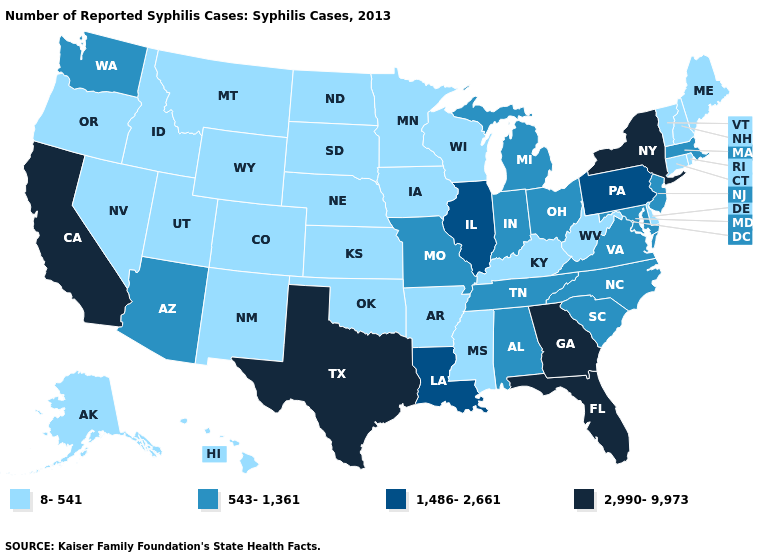What is the value of Alaska?
Keep it brief. 8-541. What is the value of Illinois?
Concise answer only. 1,486-2,661. Name the states that have a value in the range 8-541?
Give a very brief answer. Alaska, Arkansas, Colorado, Connecticut, Delaware, Hawaii, Idaho, Iowa, Kansas, Kentucky, Maine, Minnesota, Mississippi, Montana, Nebraska, Nevada, New Hampshire, New Mexico, North Dakota, Oklahoma, Oregon, Rhode Island, South Dakota, Utah, Vermont, West Virginia, Wisconsin, Wyoming. Among the states that border Louisiana , does Arkansas have the lowest value?
Quick response, please. Yes. What is the lowest value in states that border Minnesota?
Write a very short answer. 8-541. What is the lowest value in states that border Missouri?
Quick response, please. 8-541. Among the states that border Delaware , which have the lowest value?
Concise answer only. Maryland, New Jersey. What is the value of Maryland?
Short answer required. 543-1,361. Is the legend a continuous bar?
Short answer required. No. Name the states that have a value in the range 1,486-2,661?
Write a very short answer. Illinois, Louisiana, Pennsylvania. What is the highest value in the USA?
Short answer required. 2,990-9,973. Does West Virginia have the same value as Idaho?
Answer briefly. Yes. Does Massachusetts have a lower value than Wyoming?
Short answer required. No. Which states have the lowest value in the MidWest?
Quick response, please. Iowa, Kansas, Minnesota, Nebraska, North Dakota, South Dakota, Wisconsin. What is the lowest value in the USA?
Write a very short answer. 8-541. 